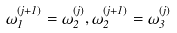<formula> <loc_0><loc_0><loc_500><loc_500>\omega _ { 1 } ^ { ( j + 1 ) } = \omega _ { 2 } ^ { ( j ) } , \omega _ { 2 } ^ { ( j + 1 ) } = \omega _ { 3 } ^ { ( j ) }</formula> 